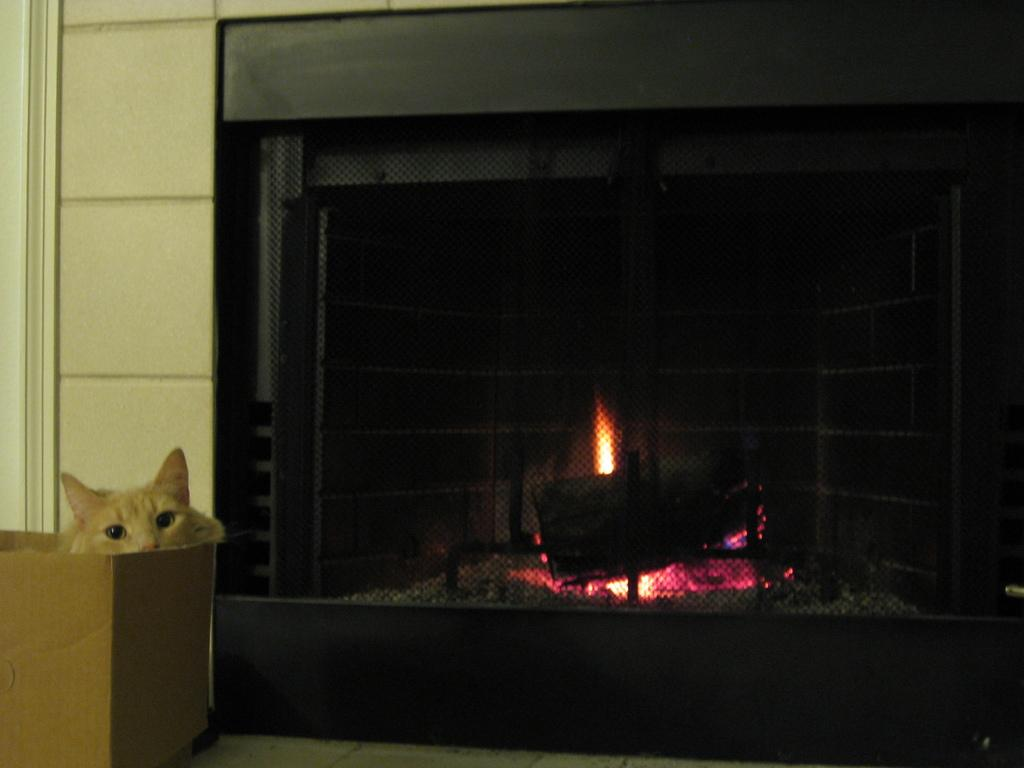What type of structure can be seen in the image? There is a fireplace in the image. What is the color of the fireplace? The fireplace is black in color. What is located on the left side of the image? There is a wall on the left side of the image. What animal is present in the image? A cat is sitting in a cardboard box in the image. Can you see any clovers growing near the fireplace in the image? There are no clovers visible in the image; it features a fireplace, a wall, and a cat sitting in a cardboard box. Is there an elbow visible in the image? There is no elbow present in the image. 